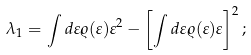Convert formula to latex. <formula><loc_0><loc_0><loc_500><loc_500>\lambda _ { 1 } = \int d \varepsilon \varrho ( \varepsilon ) \varepsilon ^ { 2 } - \left [ \int d \varepsilon \varrho ( \varepsilon ) \varepsilon \right ] ^ { 2 } ;</formula> 